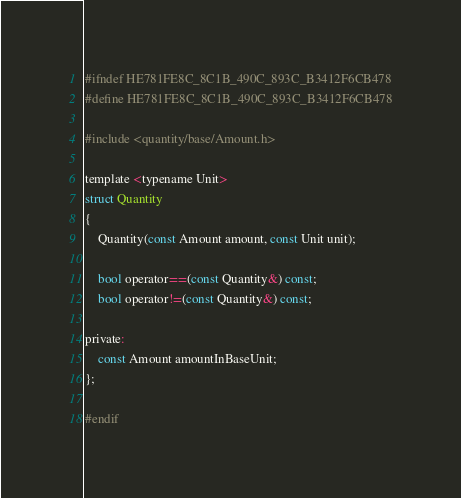<code> <loc_0><loc_0><loc_500><loc_500><_C_>#ifndef HE781FE8C_8C1B_490C_893C_B3412F6CB478
#define HE781FE8C_8C1B_490C_893C_B3412F6CB478

#include <quantity/base/Amount.h>

template <typename Unit>
struct Quantity
{
    Quantity(const Amount amount, const Unit unit);

    bool operator==(const Quantity&) const;
    bool operator!=(const Quantity&) const;

private:
    const Amount amountInBaseUnit;
};

#endif
</code> 